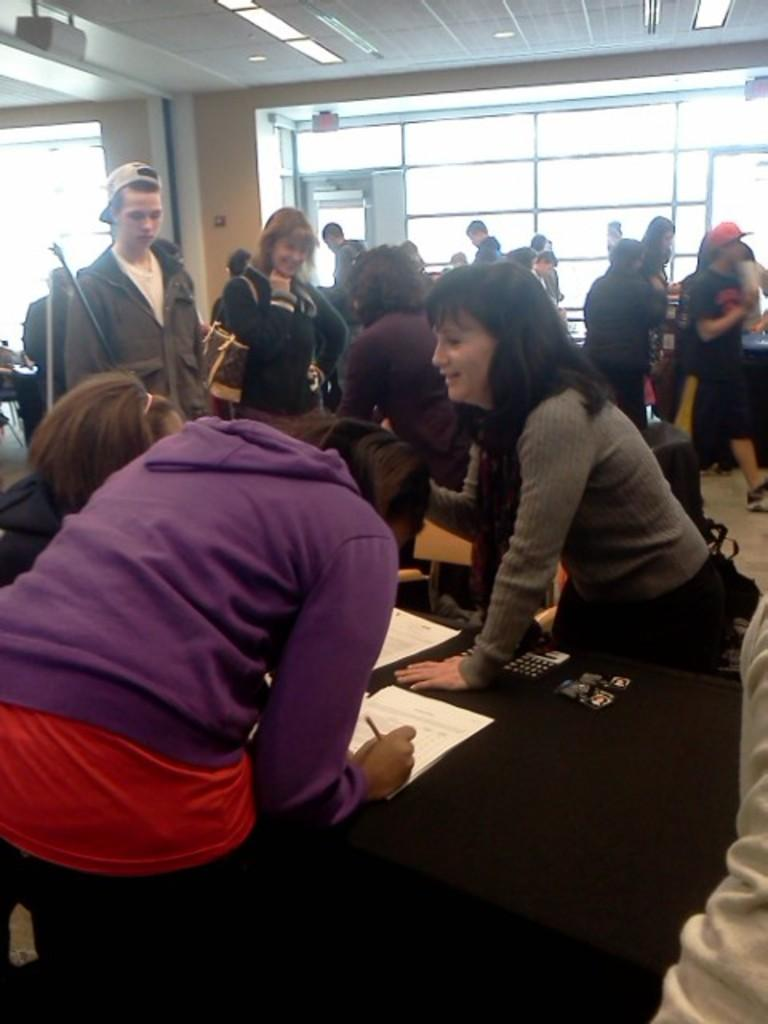What can be seen on the left side of the image? There is a group of people standing on the left side of the image. Can you describe the girl in the image? A girl is present in the image. What is the girl doing in the image? The girl is writing on a paper. What type of observation can be made about the girl's writing in space? There is no reference to space or any observations about the girl's writing in the image, as it only shows a group of people and a girl writing on a paper. 